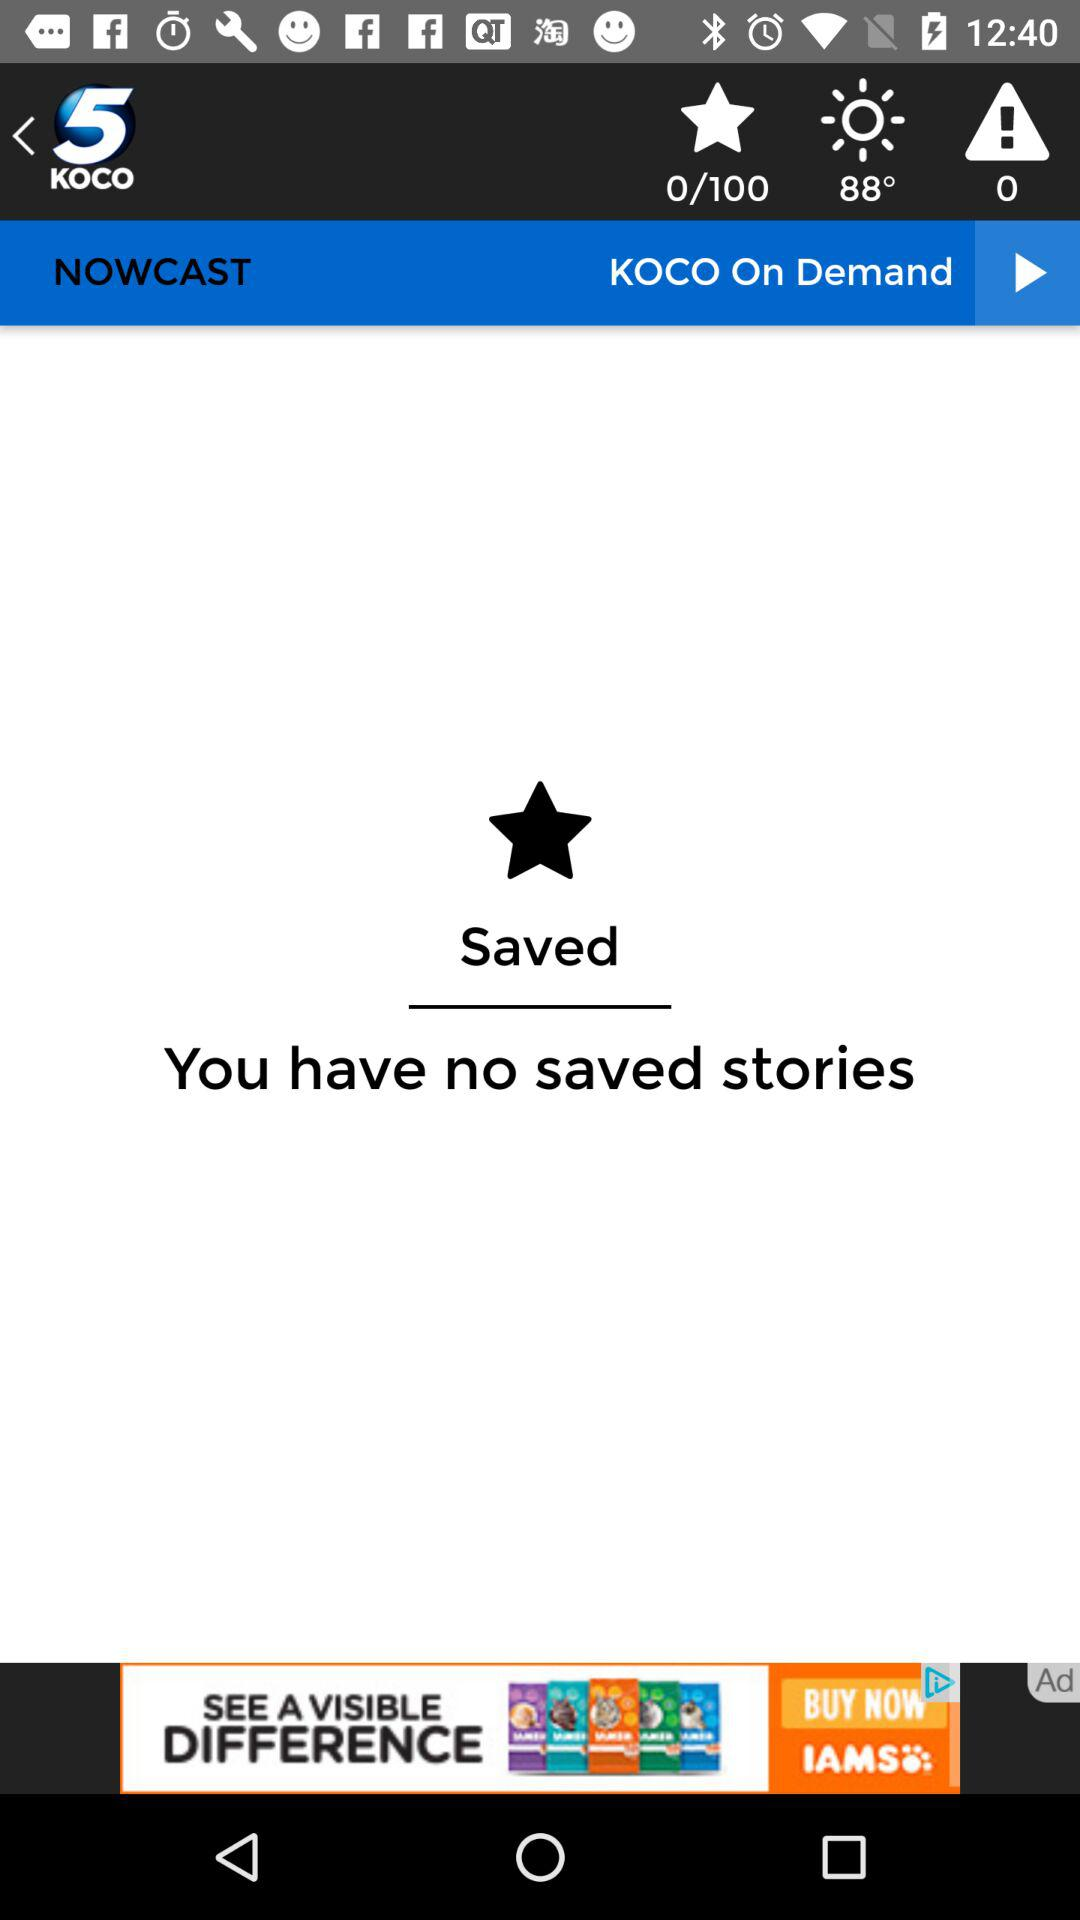How many degrees is the temperature?
Answer the question using a single word or phrase. 88° 